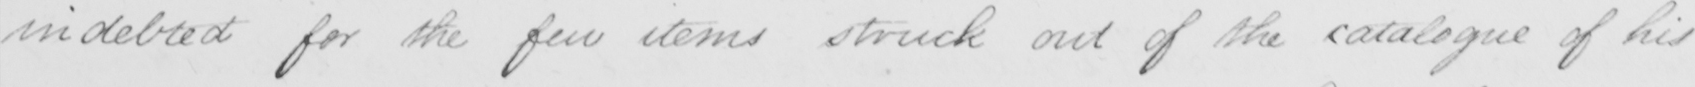Please transcribe the handwritten text in this image. indebted for the few items struck out of the catalogue of his 